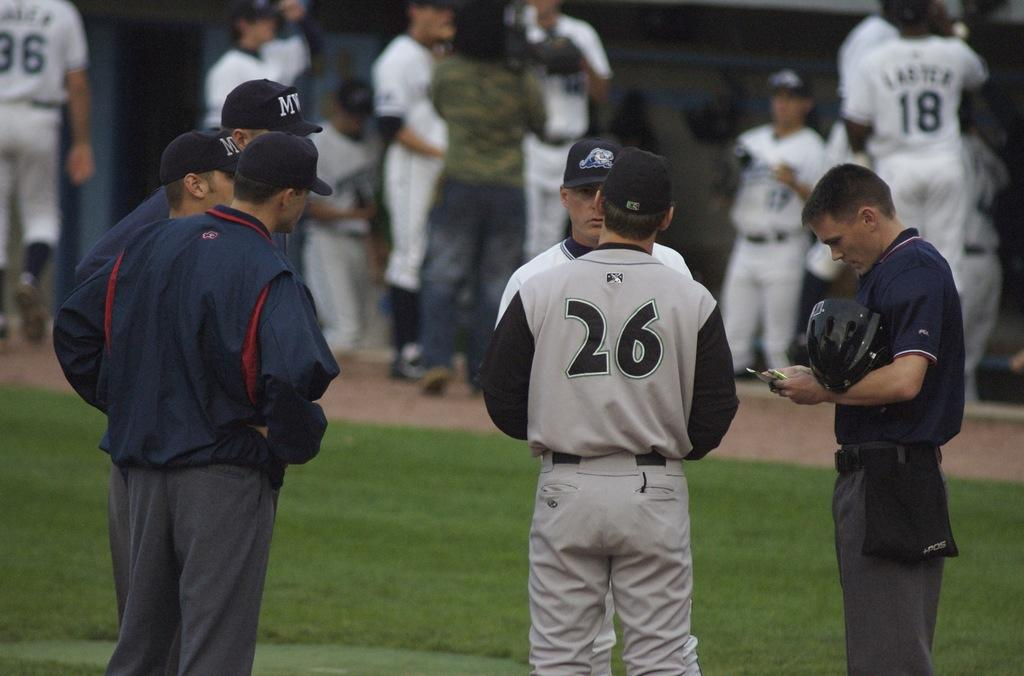<image>
Give a short and clear explanation of the subsequent image. A baseball player wears a uniform with the number 26 on the back. 